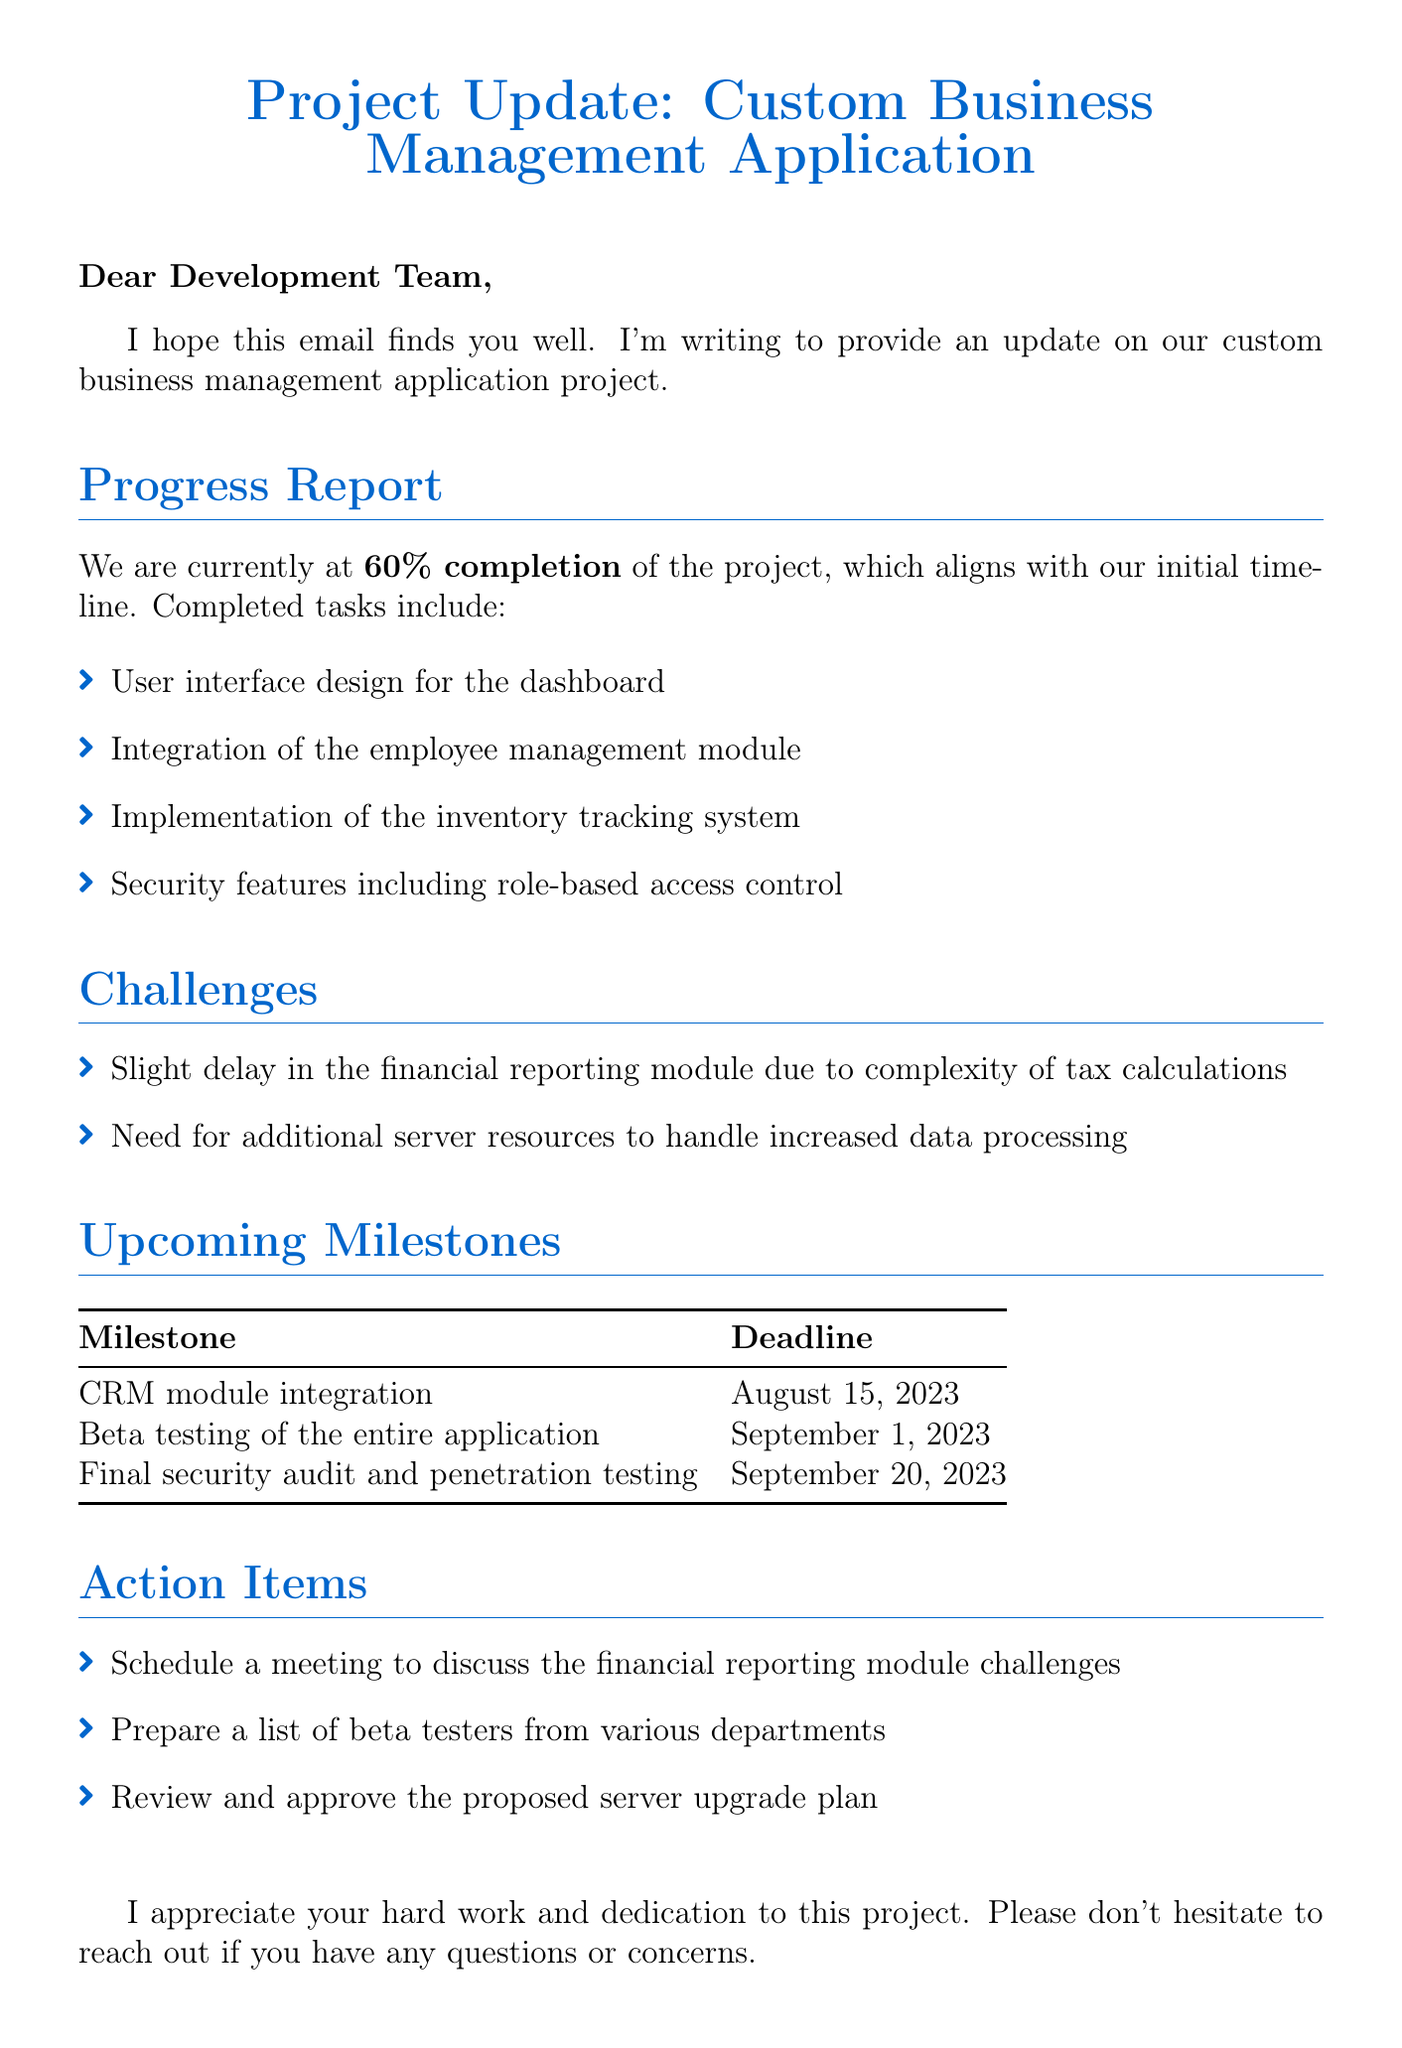What is the current completion percentage of the project? The document states that the current completion percentage of the project is 60%.
Answer: 60% What is the deadline for the CRM module integration? The document lists the deadline for the CRM module integration as August 15, 2023.
Answer: August 15, 2023 What challenge is mentioned regarding the financial reporting module? The document indicates there is a slight delay in the financial reporting module due to the complexity of tax calculations.
Answer: Complexity of tax calculations Who is the sender of the email? The email concludes with the sender's name, Carlos Mendoza, who is the IT Manager.
Answer: Carlos Mendoza How many completed tasks are listed in the progress report? The document enumerates four completed tasks in the progress report.
Answer: Four What is the next upcoming milestone after beta testing? The document states that the next milestone after beta testing is the final security audit and penetration testing.
Answer: Final security audit and penetration testing What task is listed under action items about server resources? One of the action items is to review and approve the proposed server upgrade plan.
Answer: Review and approve the proposed server upgrade plan What date is scheduled for beta testing? According to the document, beta testing is scheduled for September 1, 2023.
Answer: September 1, 2023 What is the tone of the closing statement in the email? The closing statement expresses appreciation for the team's hard work and encourages communication regarding any questions or concerns.
Answer: Appreciation and encouragement 